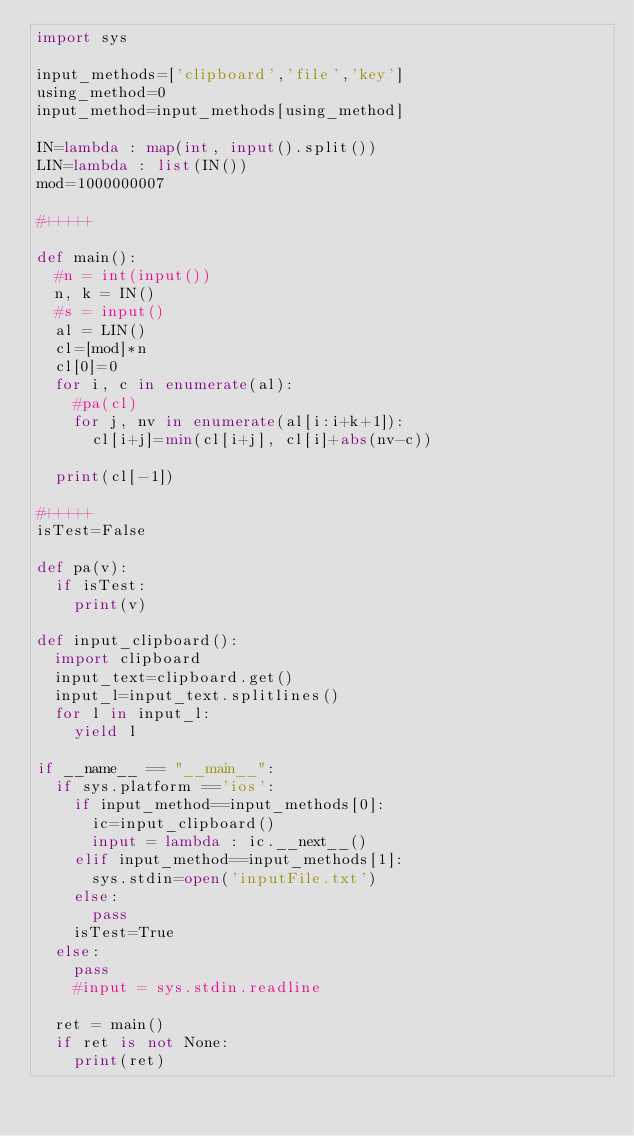Convert code to text. <code><loc_0><loc_0><loc_500><loc_500><_Python_>import sys

input_methods=['clipboard','file','key']
using_method=0
input_method=input_methods[using_method]

IN=lambda : map(int, input().split())
LIN=lambda : list(IN())
mod=1000000007

#+++++

def main():
	#n = int(input())
	n, k = IN()
	#s = input()
	al = LIN()
	cl=[mod]*n
	cl[0]=0
	for i, c in enumerate(al):
		#pa(cl)
		for j, nv in enumerate(al[i:i+k+1]):
			cl[i+j]=min(cl[i+j], cl[i]+abs(nv-c))
	
	print(cl[-1])
	
#+++++
isTest=False

def pa(v):
	if isTest:
		print(v)
		
def input_clipboard():
	import clipboard
	input_text=clipboard.get()
	input_l=input_text.splitlines()
	for l in input_l:
		yield l

if __name__ == "__main__":
	if sys.platform =='ios':
		if input_method==input_methods[0]:
			ic=input_clipboard()
			input = lambda : ic.__next__()
		elif input_method==input_methods[1]:
			sys.stdin=open('inputFile.txt')
		else:
			pass
		isTest=True
	else:
		pass
		#input = sys.stdin.readline
			
	ret = main()
	if ret is not None:
		print(ret)</code> 